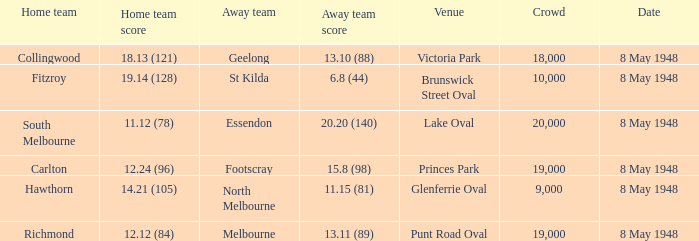Which home team has a score of 11.12 (78)? South Melbourne. 